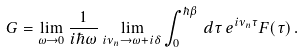Convert formula to latex. <formula><loc_0><loc_0><loc_500><loc_500>G = \lim _ { \omega \rightarrow 0 } \frac { 1 } { i \hbar { \omega } } \lim _ { i \nu _ { n } \rightarrow \omega + i \delta } \int ^ { \hbar { \beta } } _ { 0 } \, d \tau \, e ^ { i \nu _ { n } \tau } F ( \tau ) \, .</formula> 